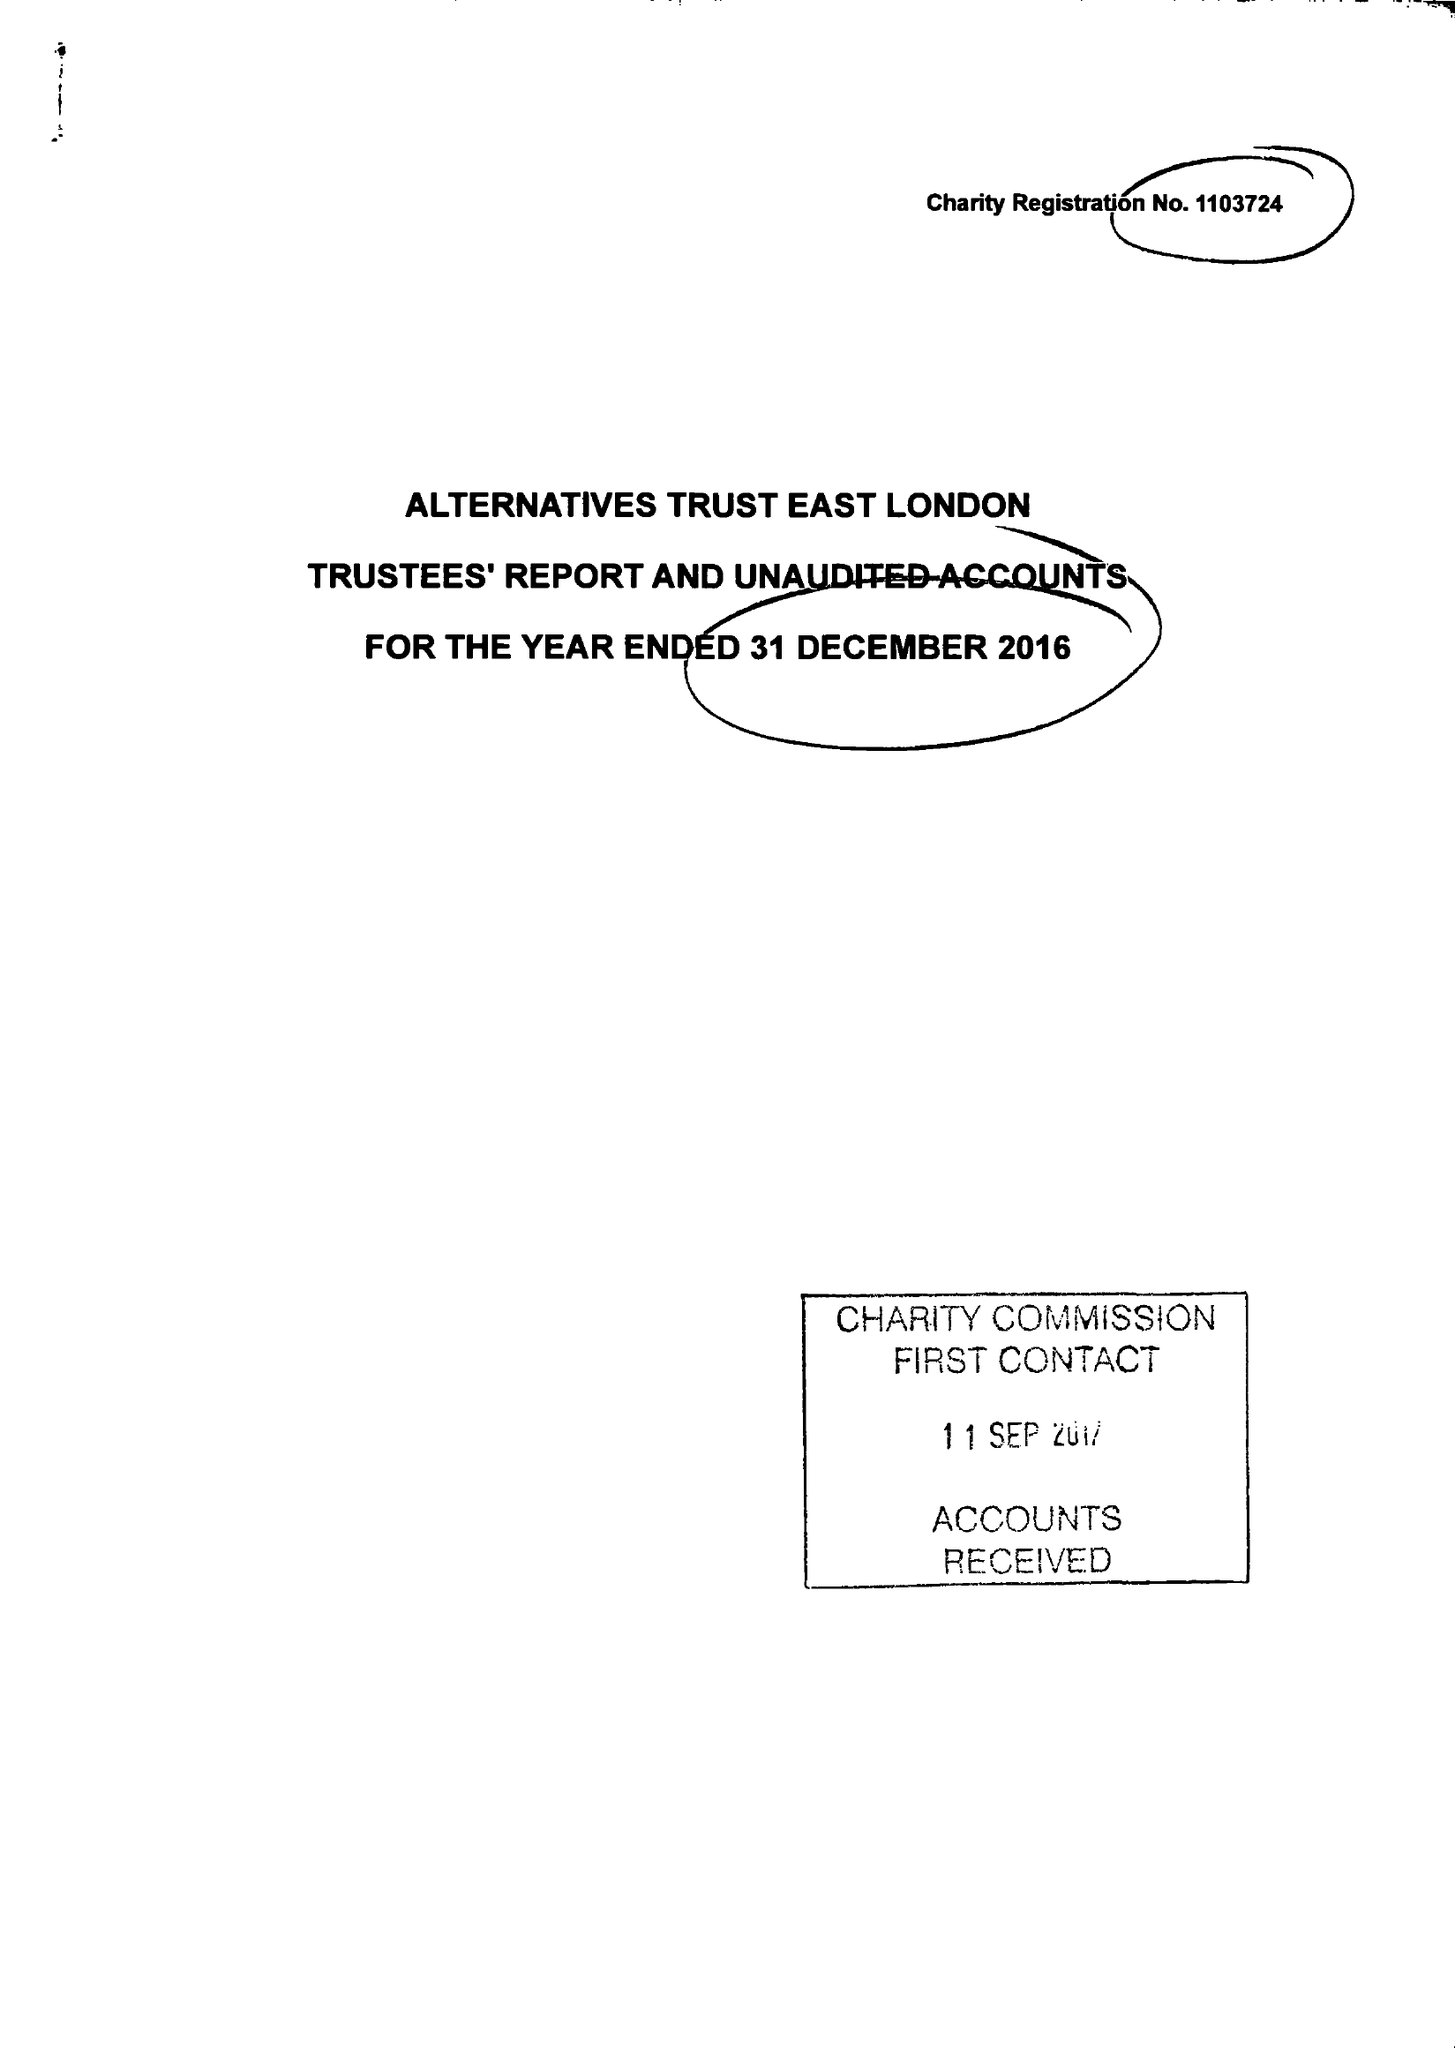What is the value for the spending_annually_in_british_pounds?
Answer the question using a single word or phrase. 163356.00 